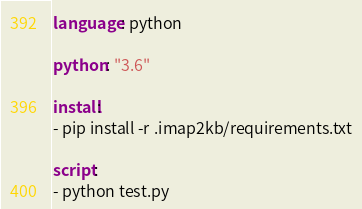<code> <loc_0><loc_0><loc_500><loc_500><_YAML_>language: python

python: "3.6"

install:
- pip install -r .imap2kb/requirements.txt

script:
- python test.py
</code> 